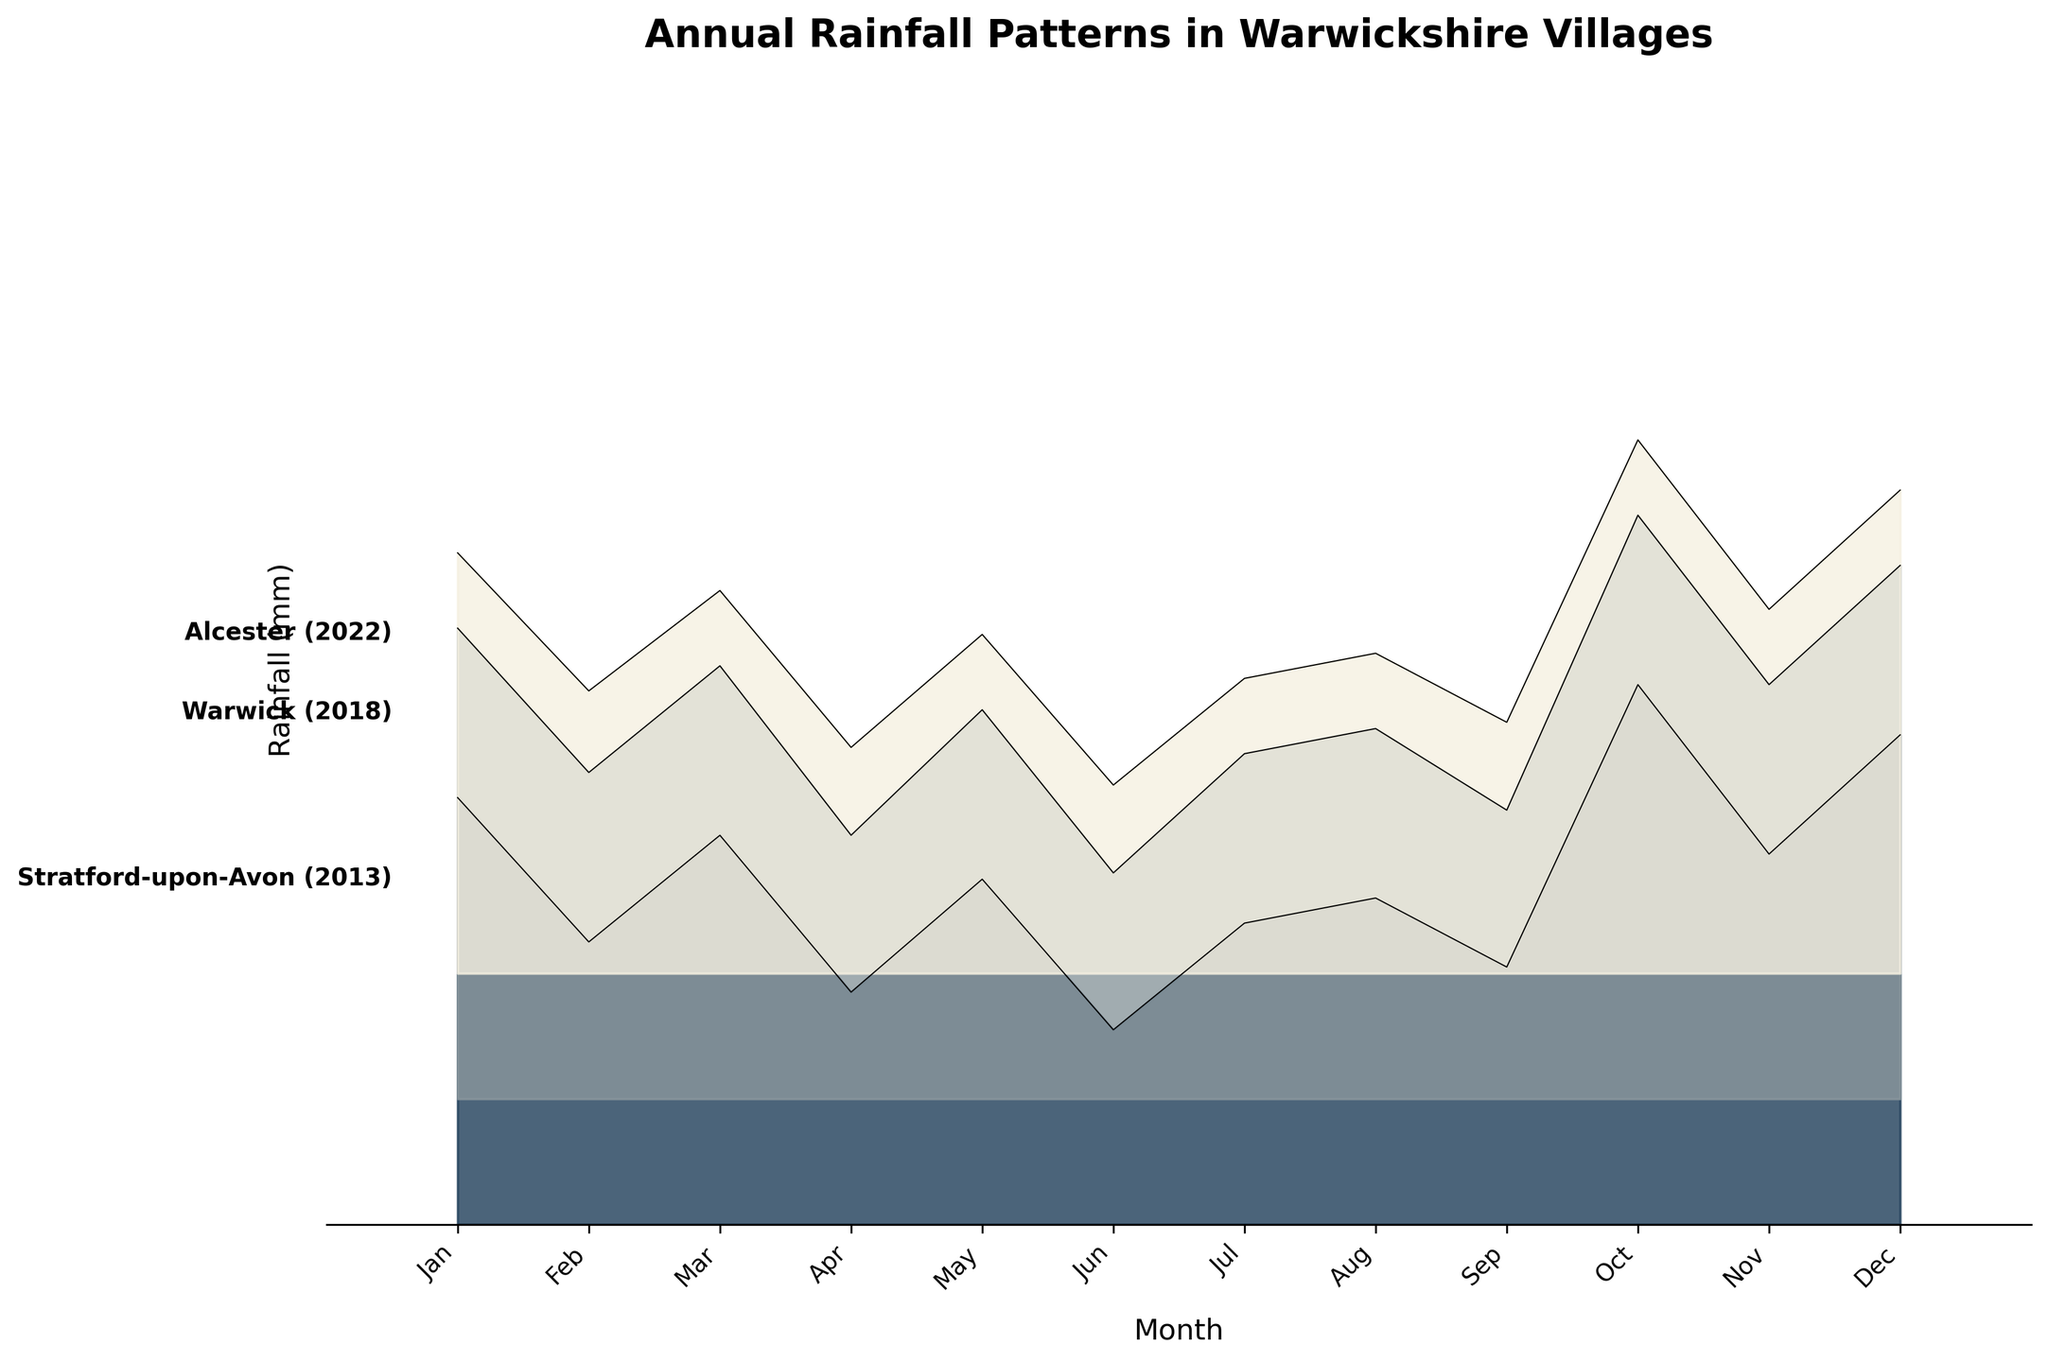What's the title of the plot? The title is above the plot and typically summarizes the main focus of the figure. It reads "Annual Rainfall Patterns in Warwickshire Villages".
Answer: Annual Rainfall Patterns in Warwickshire Villages What are the labels on the x-axis? The x-axis labels represent the months of the year and can be seen at the bottom of the plot. They are Jan, Feb, Mar, Apr, May, Jun, Jul, Aug, Sep, Oct, Nov, and Dec.
Answer: Jan, Feb, Mar, Apr, May, Jun, Jul, Aug, Sep, Oct, Nov, Dec Which village had the highest rainfall in November 2018? By observing the plot, we focus on the year 2018, then identify the November data points. The highest data point for November 2018 is in Warwick.
Answer: Warwick What is the overall trend of rainfall in Stratford-upon-Avon across the given years? To determine the trend, we look at the plot lines for Stratford-upon-Avon. The values remain fairly consistent across the years, indicating no major increases or decreases.
Answer: Fairly consistent Which month tends to have the lowest amounts of rainfall across all villages? By scanning across months for all villages, we see that June consistently has lower rainfall values compared to other months.
Answer: June Compare the highest rainfall month of Henley-in-Arden in 2022 to 2013. Which year had a higher peak and in what month? We find the highest peaks for Henley-in-Arden in both years and compare them. In 2022, the peak is in October, higher than the peak in 2013, which is also in October.
Answer: 2022, October Which village had the most consistent rainfall throughout the year in 2022? To identify consistency, we look for a village in 2022 where the plot line remains relatively flat. Stratford-upon-Avon displays the most consistent pattern.
Answer: Stratford-upon-Avon How many different villages are represented in the plot? Each unique colored line represents a different village. By checking the figure, we can see that there are five distinct villages: Stratford-upon-Avon, Warwick, Alcester, Henley-in-Arden, and Shipston-on-Stour.
Answer: 5 In 2013, which village showed the steepest increase in rainfall from August to October? Observing 2013, we analyze the increase from August to October for each village. Warwick has the steepest increase in rainfall during this period.
Answer: Warwick 